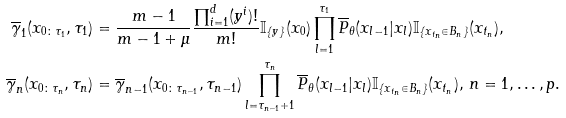<formula> <loc_0><loc_0><loc_500><loc_500>\overline { \gamma } _ { 1 } ( x _ { 0 \colon \tau _ { 1 } } , \tau _ { 1 } ) & = \frac { m - 1 } { m - 1 + \mu } \frac { \prod _ { i = 1 } ^ { d } ( y ^ { i } ) ! } { m ! } \mathbb { I } _ { \{ y \} } ( x _ { 0 } ) \prod _ { l = 1 } ^ { \tau _ { 1 } } \overline { P } _ { \theta } ( x _ { l - 1 } | x _ { l } ) \mathbb { I } _ { \{ x _ { t _ { n } } \in B _ { n } \} } ( x _ { t _ { n } } ) , \\ \overline { \gamma } _ { n } ( x _ { 0 \colon \tau _ { n } } , \tau _ { n } ) & = \overline { \gamma } _ { n - 1 } ( x _ { 0 \colon \tau _ { n - 1 } } , \tau _ { n - 1 } ) \prod _ { l = \tau _ { n - 1 } + 1 } ^ { \tau _ { n } } \overline { P } _ { \theta } ( x _ { l - 1 } | x _ { l } ) \mathbb { I } _ { \{ x _ { t _ { n } } \in B _ { n } \} } ( x _ { t _ { n } } ) , \, n = 1 , \dots , p .</formula> 